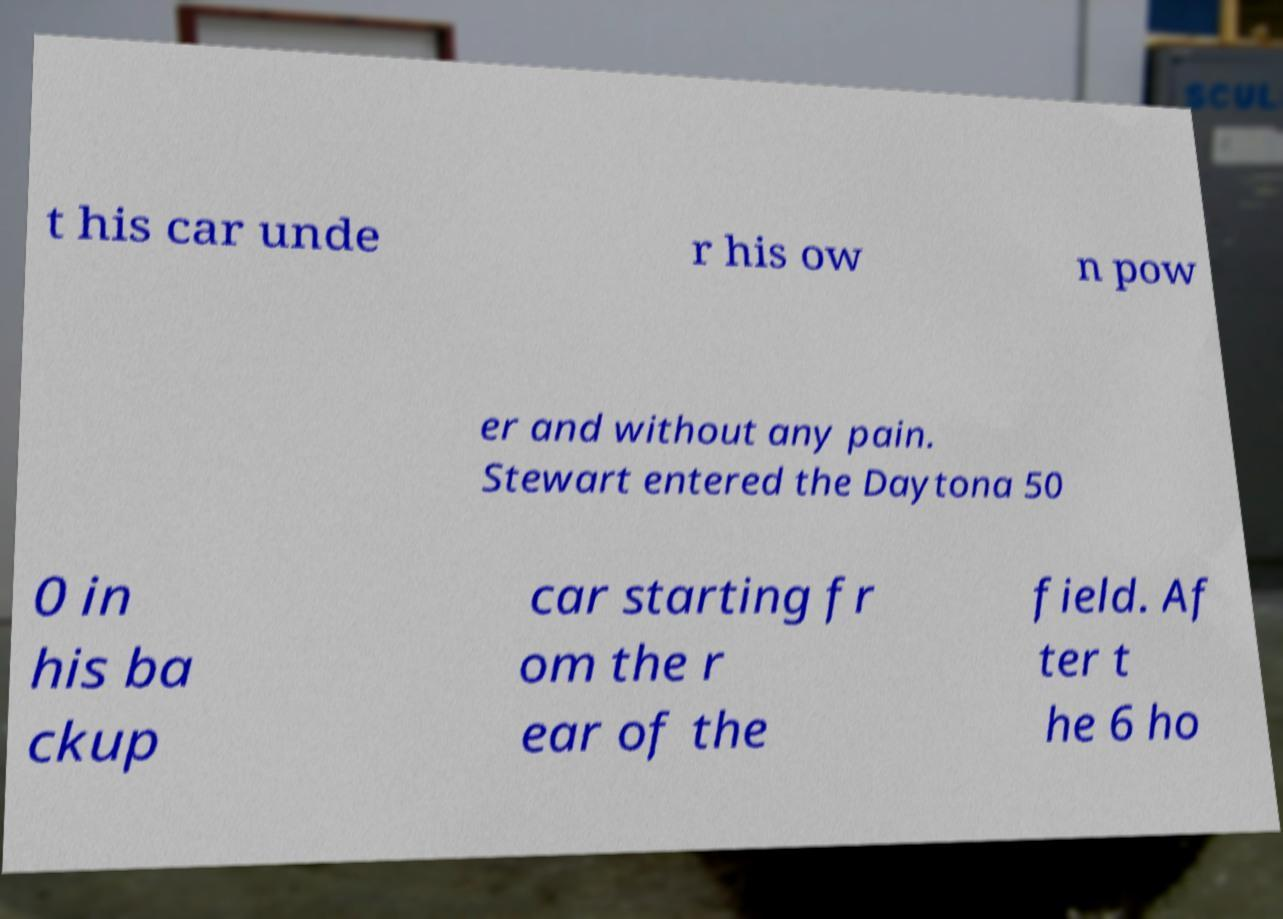What messages or text are displayed in this image? I need them in a readable, typed format. t his car unde r his ow n pow er and without any pain. Stewart entered the Daytona 50 0 in his ba ckup car starting fr om the r ear of the field. Af ter t he 6 ho 